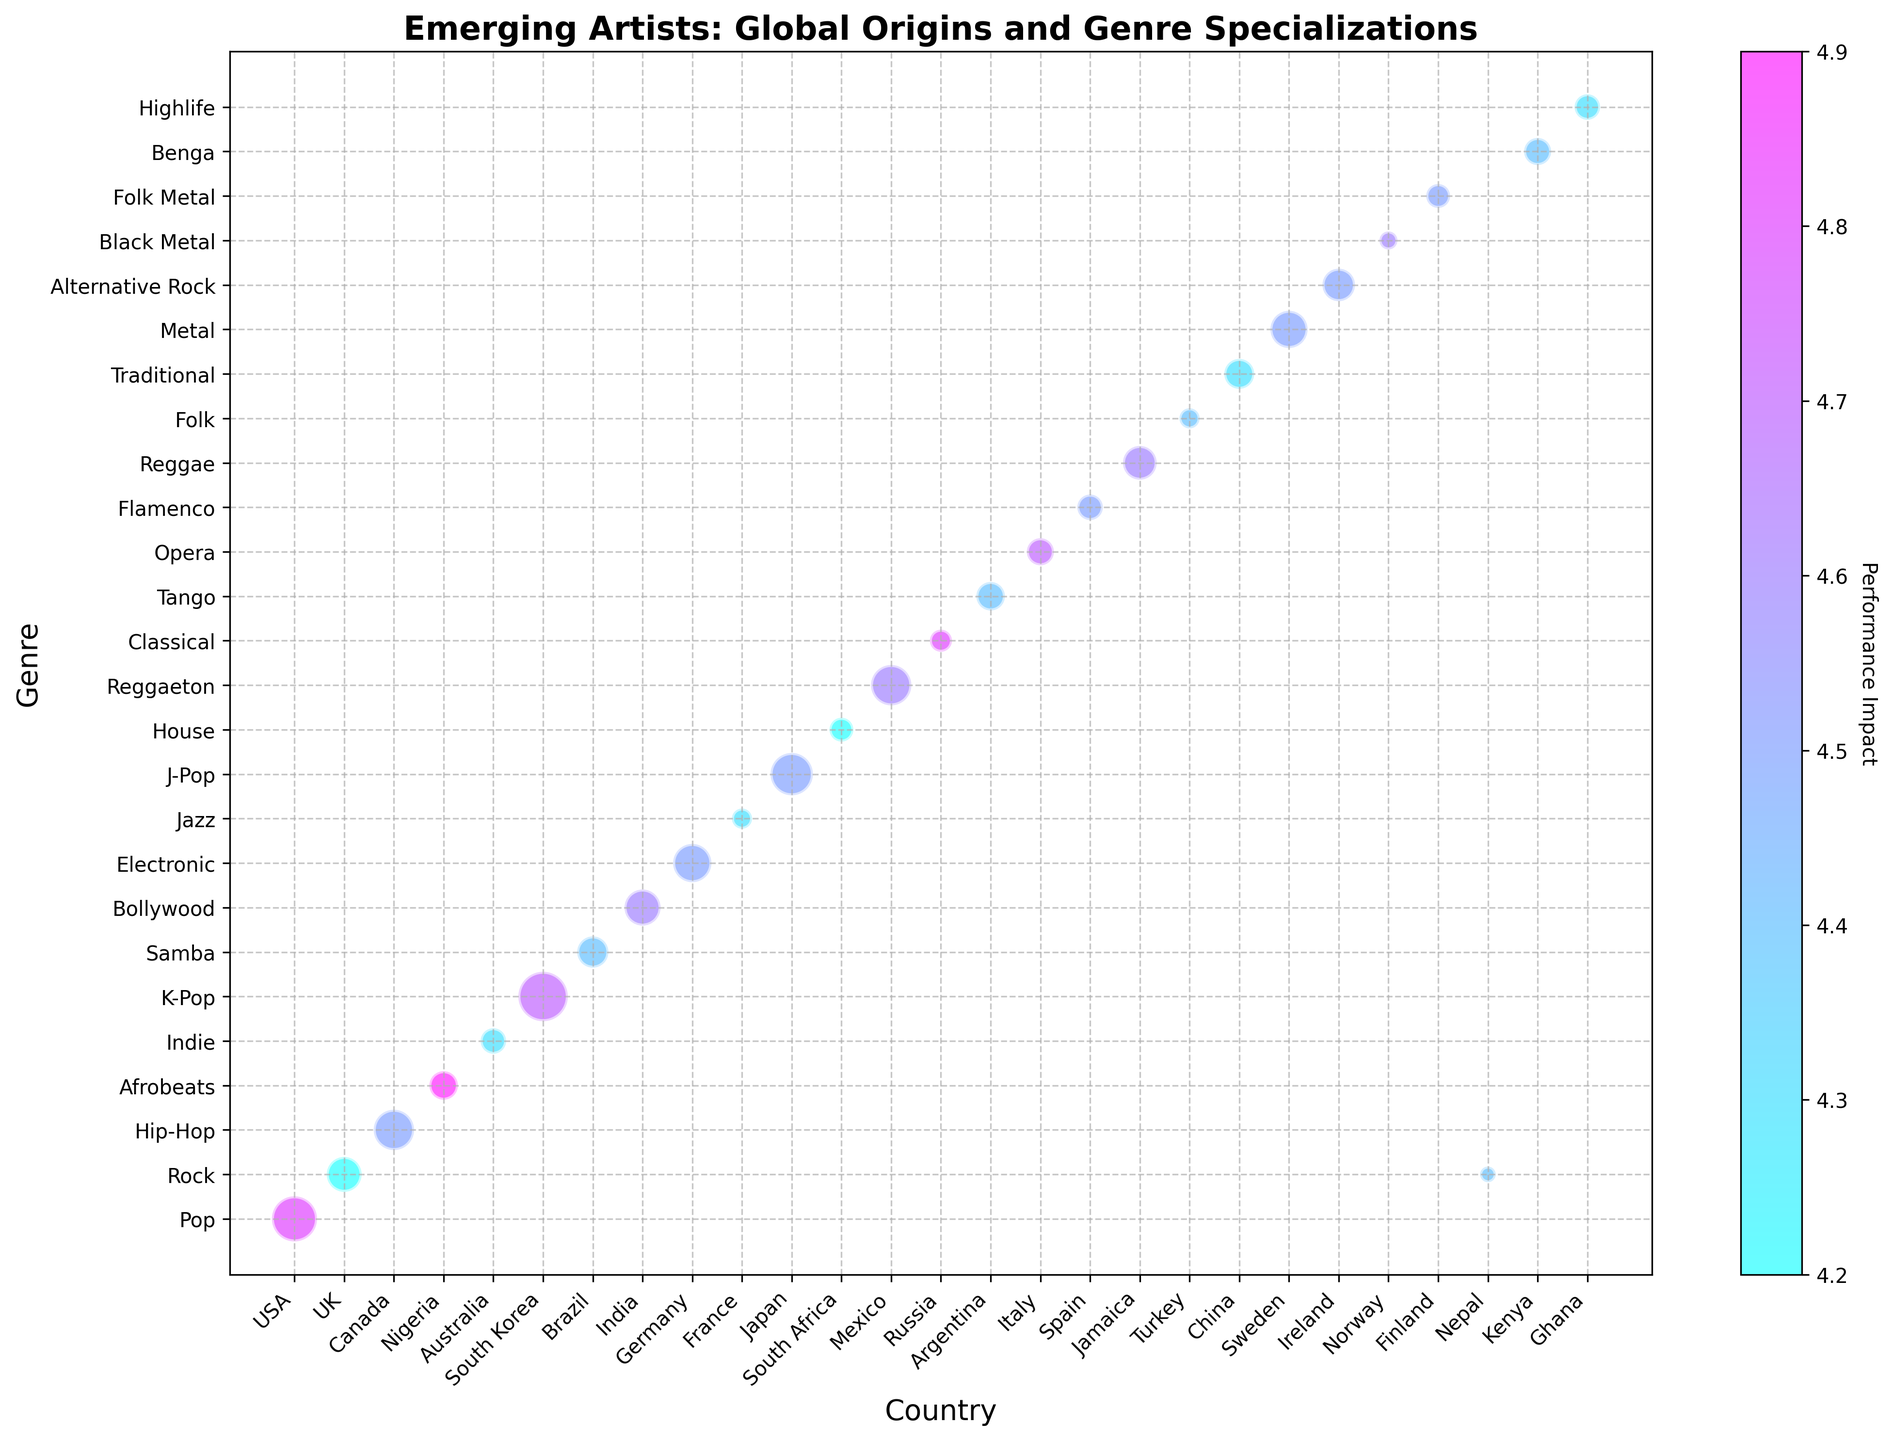What is the country with the highest number of emerging artists in the Pop genre? The bubble chart indicates bubble sizes corresponding to the number of artists. We look for the largest bubble associated with "Pop" on the y-axis and check its corresponding country on the x-axis.
Answer: USA Which genre has the highest performance impact, and what is the associated country? The color bar indicates the performance impact. Look for the genre with the most intense color. Afrobeats has the highest performance impact, and the corresponding country is Nigeria.
Answer: Afrobeats, Nigeria Compare the number of artists between K-Pop and Hip-Hop genres. Which one has more emerging artists, and by how many? Compare the sizes of the bubbles for K-Pop (South Korea) and Hip-Hop (Canada) on the chart. K-Pop has 30 artists, whereas Hip-Hop has 20 artists. The difference is 30 - 20.
Answer: K-Pop, by 10 artists What is the average performance impact for the artists from Europe? Consider UK, Germany, France, Russia, Italy, Spain, Sweden, Ireland, and Norway. Average performance impact = (4.2 + 4.5 + 4.3 + 4.8 + 4.7 + 4.5 + 4.5 + 4.5 + 4.6) / 9 = 40.6 / 9
Answer: 4.5 Which country has the smallest number of emerging artists, and what is their genre? Look for the smallest bubble on the chart. Nepal has the smallest bubble with 3 artists, and the genre is Rock.
Answer: Nepal, Rock What is the difference in average performance impact between traditional and modern music genres? Modern genres include Pop, Rock, Hip-Hop, K-Pop, and Electronic. Traditional genres include Classical, Opera, and Folk. Average impact modern = (4.8 + 4.2 + 4.5 + 4.7 + 4.5) / 5 = 22.7 / 5 = 4.54
Average impact traditional = (4.8 + 4.7 + 4.4) / 3 = 13.9 / 3 = 4.633
Difference = 4.633 - 4.54
Answer: 0.093 Which genre indicates the strongest presence of emerging artists from a single country? The largest bubble indicates the strongest presence. K-Pop (South Korea) with 30 artists shows the strongest presence.
Answer: K-Pop, South Korea Among the genres with a performance impact of 4.6, which country corresponds to the largest number of artists? Look for bubbles with intense coloring for 4.6 impact in the color bar. The largest bubble corresponds to K-Pop (South Korea) with 16 artists.
Answer: K-Pop, South Korea 